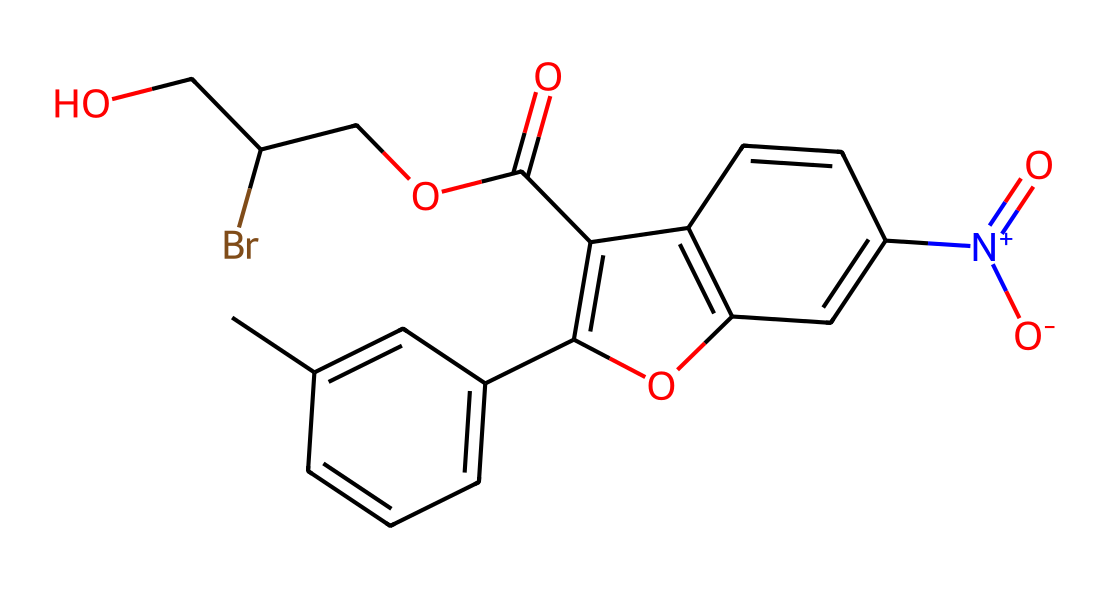What is the molecular formula of the compound? To determine the molecular formula, count the number of each type of atom present in the SMILES representation. There are 18 carbon (C) atoms, 14 hydrogen (H) atoms, 3 oxygen (O) atoms, 1 bromine (Br) atom, and 1 nitrogen (N) atom. Therefore, the molecular formula is C18H14BrN1O3.
Answer: C18H14BrN1O3 How many rings are present in the structure? Analyzing the structure indicated by the SMILES, there are two distinct rings indicated by the notation 1 and 2, leading to the conclusion that there are 3 rings total.
Answer: 3 What functional groups are present in this compound? Identifying the functional groups in the structure reveals a carboxylic acid group (C(=O)O), a bromoalkyl group (Br), and a quaternary ammonium group (N+).
Answer: carboxylic acid, bromoalkyl, quaternary ammonium What is the significance of the nitrogen in the structure? The nitrogen is positively charged (N+) and contributes to the compound's photoactive properties, which are crucial for its function as a photoresist in holographic displays.
Answer: photoactive Which part of the structure is responsible for its photosensitivity? The presence of the conjugated system involving the ring structures and the nitrogen creates the conditions for the compound to exhibit photosensitivity when exposed to light, particularly due to the alternating double bonds.
Answer: conjugated system What type of chemical reaction could this compound undergo upon light exposure? Upon light exposure, this compound is likely to undergo a cross-linking reaction due to the reactivity of the double bonds in the conjugated systems, forming a polymer network as part of the photoresist process.
Answer: cross-linking reaction 